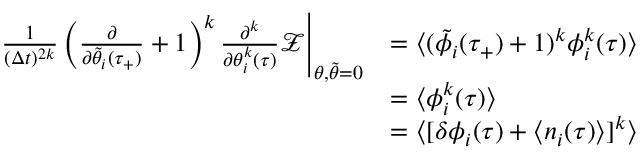<formula> <loc_0><loc_0><loc_500><loc_500>\begin{array} { r l } { \frac { 1 } { ( \Delta t ) ^ { 2 k } } \left ( \frac { \partial } { \partial \tilde { \theta } _ { i } ( \tau _ { + } ) } + 1 \right ) ^ { k } \frac { \partial ^ { k } } { \partial \theta _ { i } ^ { k } ( \tau ) } \mathcal { Z } \Big | _ { \theta , \tilde { \theta } = 0 } } & { = \langle ( \tilde { \phi } _ { i } ( \tau _ { + } ) + 1 ) ^ { k } \phi _ { i } ^ { k } ( \tau ) \rangle } \\ & { = \langle \phi _ { i } ^ { k } ( \tau ) \rangle } \\ & { = \langle [ \delta \phi _ { i } ( \tau ) + \langle n _ { i } ( \tau ) \rangle ] ^ { k } \rangle } \end{array}</formula> 